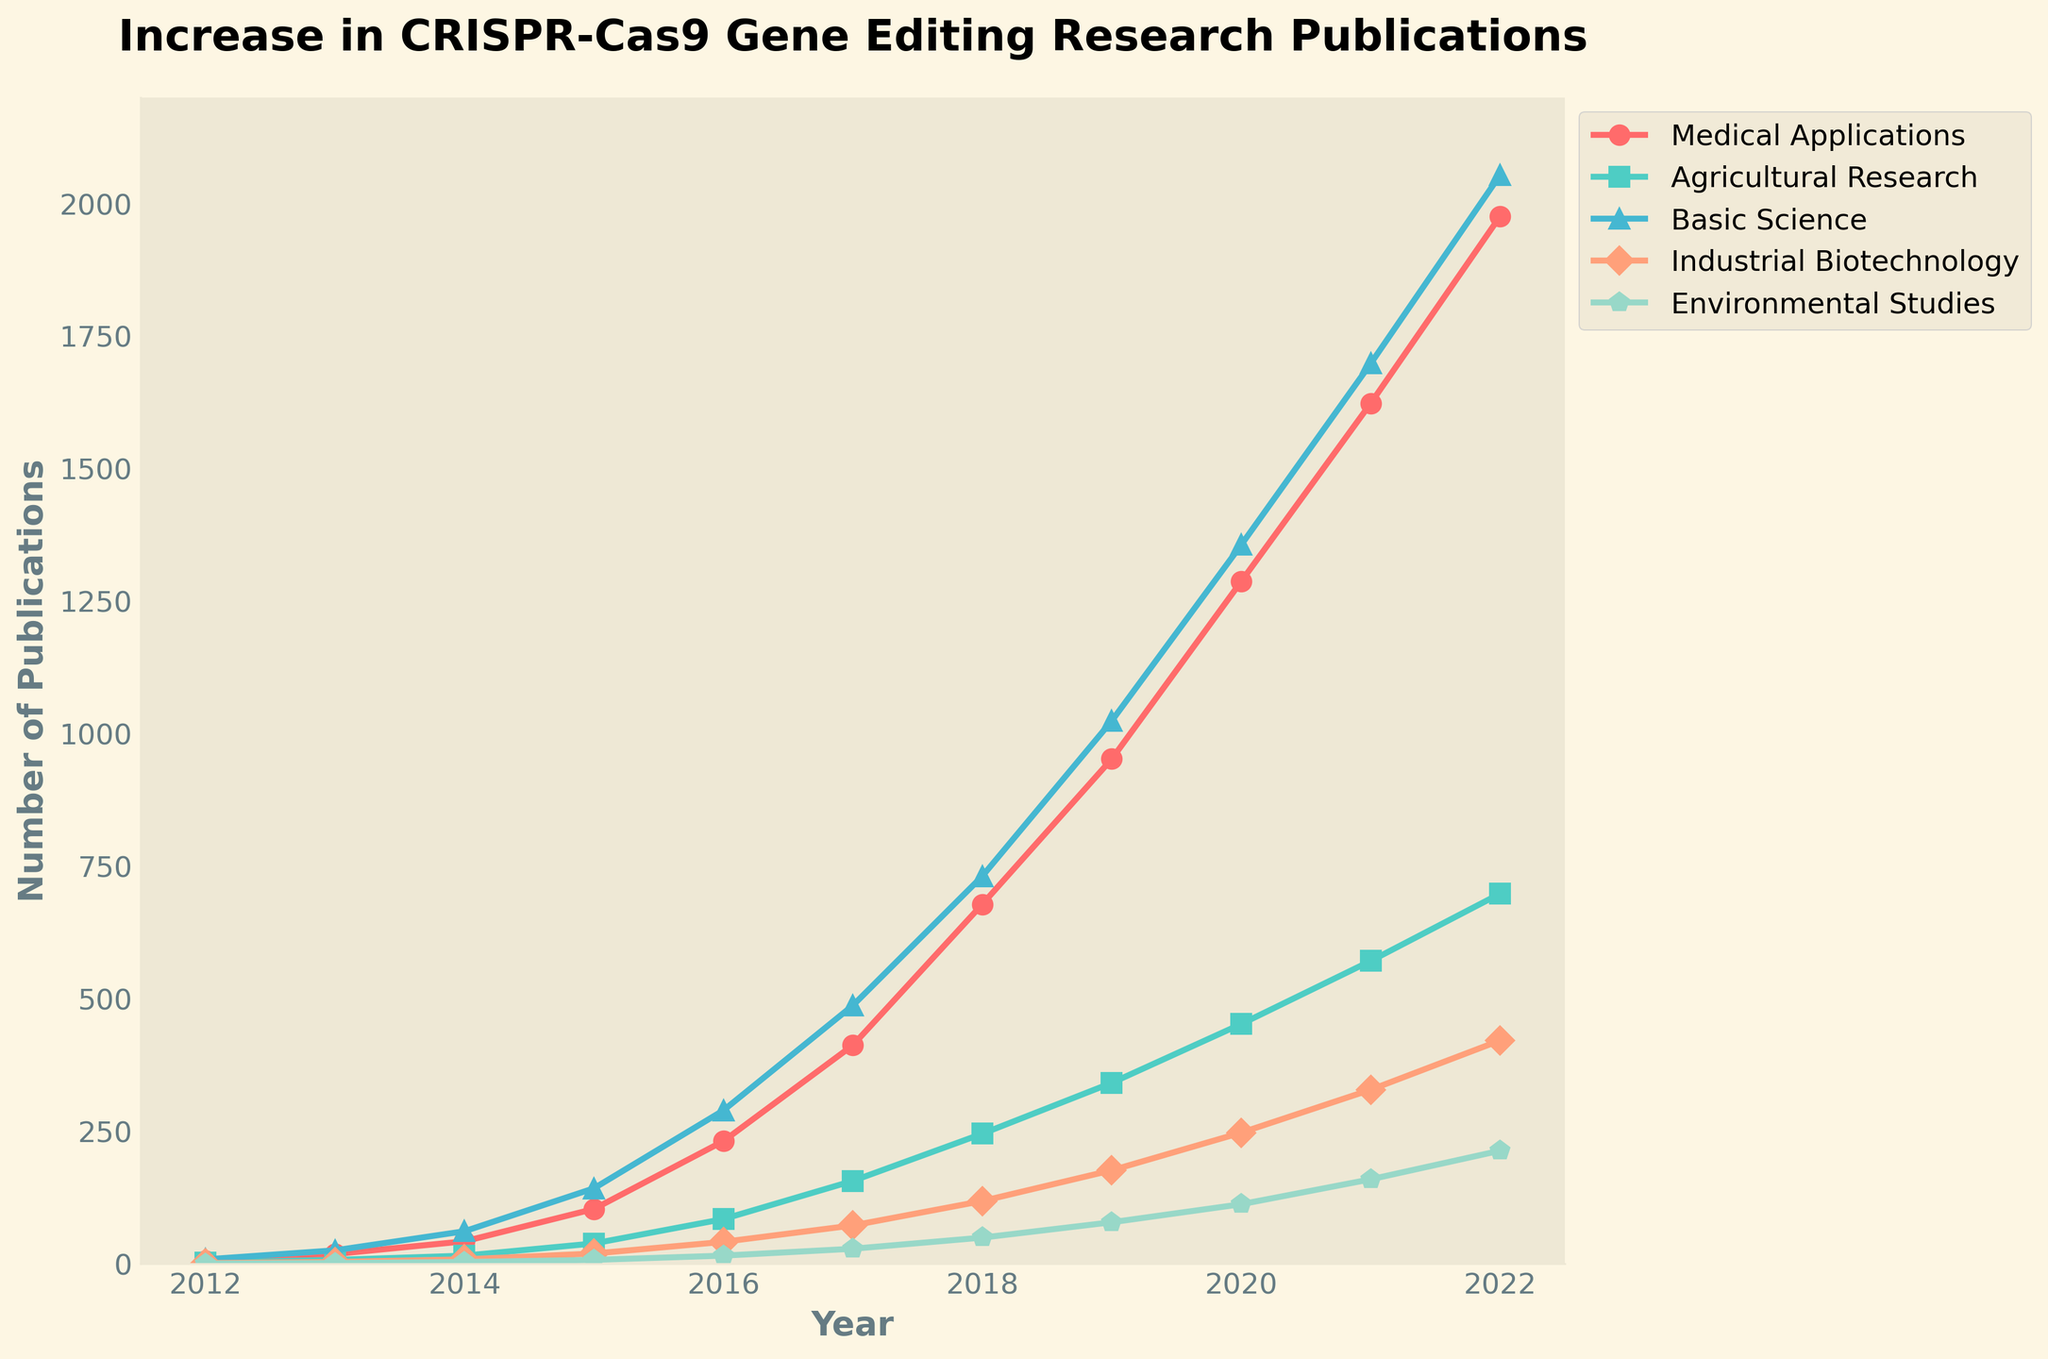What year did medical applications surpass 1000 publications? To determine this, look at the "Medical Applications" line and find the year where the number of publications exceeds 1000. From the plot, it is the year 2019 with 952 publications.
Answer: 2019 Which application area had the smallest number of publications in 2022? To determine this, look at the end points of all lines in 2022 and compare their respective values. "Environmental Studies" has the smallest number with 213 publications.
Answer: Environmental Studies Between which years did agricultural research see the largest increase in publications? Calculate the difference in number of publications for each year and observe which two consecutive years have the maximum difference. The largest increase for Agricultural Research is between 2018 (245) and 2019 (341), a difference of 96.
Answer: 2018 and 2019 How many more publications did industrial biotechnology have compared to basic science in 2020? Look at the respective values for "Industrial Biotechnology" and "Basic Science" in 2020. Industrial Biotechnology had 247 publications, and Basic Science had 1356 publications. Subtract the smaller from the larger: 1356 - 247 = 1109.
Answer: 1109 In which year did environmental studies first reach double digits? Look at the "Environmental Studies" line and identify the first point where the publications are 10 or more. This is the year 2016 with 15 publications.
Answer: 2016 